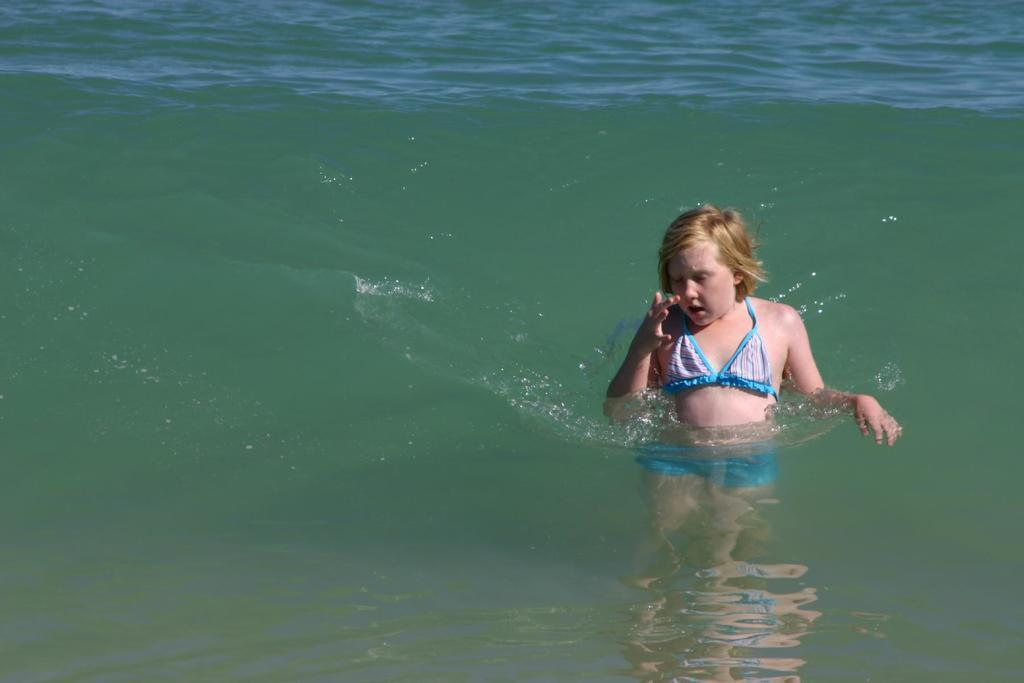Where was the image taken? The image is taken outdoors. What can be seen in the background of the image? There is a river with water in the image. Who or what is in the water in the middle of the image? There is a girl in the water in the middle of the image. What type of dolls can be seen holding a sign in the image? There are no dolls or signs present in the image. How does the girl show her excitement in the image? The image does not depict the girl's emotions or expressions, so it cannot be determined how she shows her excitement. 